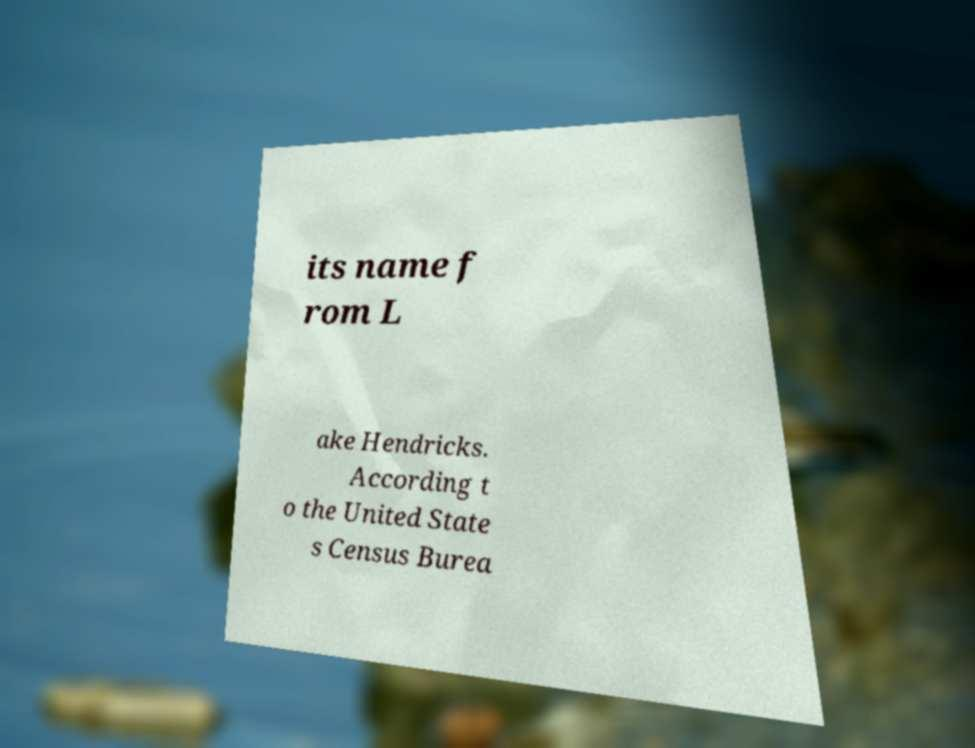Please identify and transcribe the text found in this image. its name f rom L ake Hendricks. According t o the United State s Census Burea 